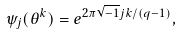Convert formula to latex. <formula><loc_0><loc_0><loc_500><loc_500>\psi _ { j } ( \theta ^ { k } ) = e ^ { 2 \pi \sqrt { - 1 } j k / ( q - 1 ) } ,</formula> 